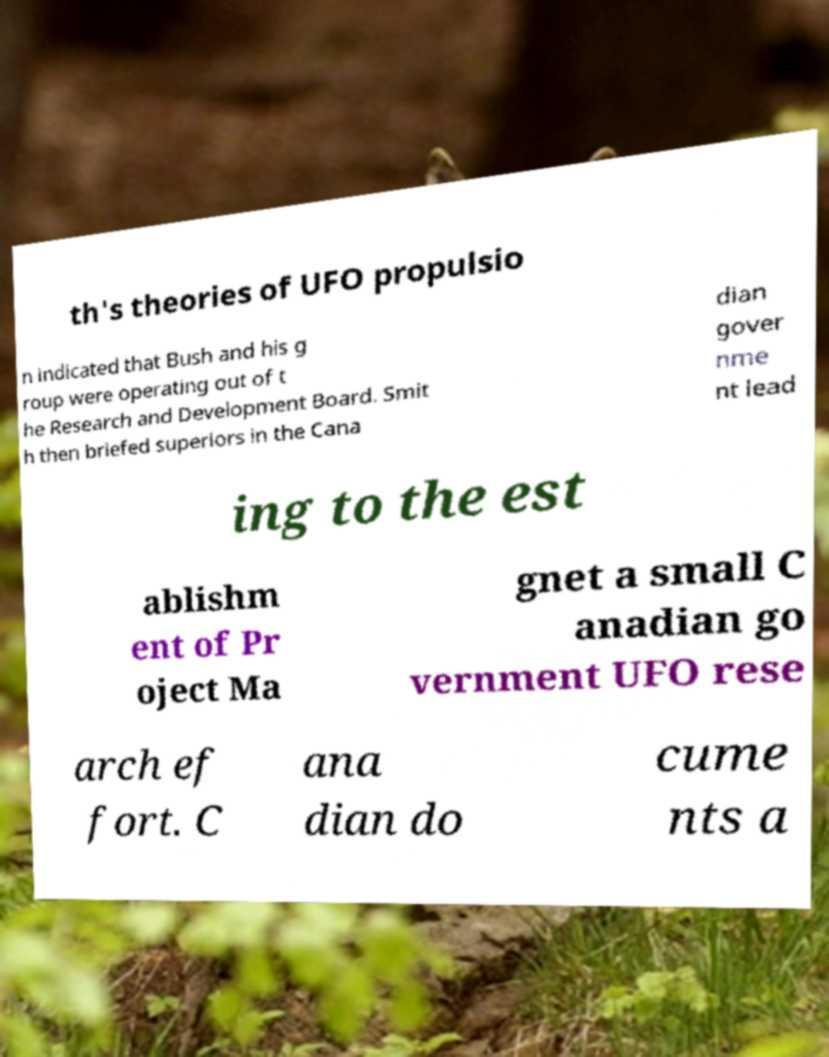Please identify and transcribe the text found in this image. th's theories of UFO propulsio n indicated that Bush and his g roup were operating out of t he Research and Development Board. Smit h then briefed superiors in the Cana dian gover nme nt lead ing to the est ablishm ent of Pr oject Ma gnet a small C anadian go vernment UFO rese arch ef fort. C ana dian do cume nts a 